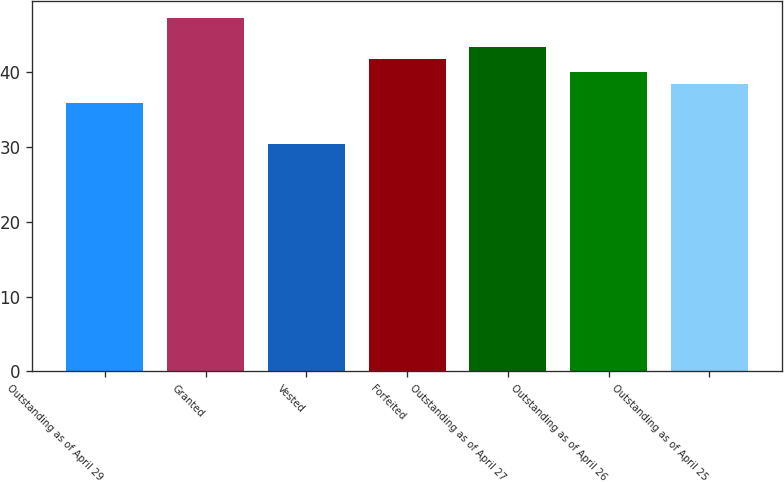Convert chart. <chart><loc_0><loc_0><loc_500><loc_500><bar_chart><fcel>Outstanding as of April 29<fcel>Granted<fcel>Vested<fcel>Forfeited<fcel>Outstanding as of April 27<fcel>Outstanding as of April 26<fcel>Outstanding as of April 25<nl><fcel>35.79<fcel>47.17<fcel>30.35<fcel>41.71<fcel>43.39<fcel>40.03<fcel>38.35<nl></chart> 